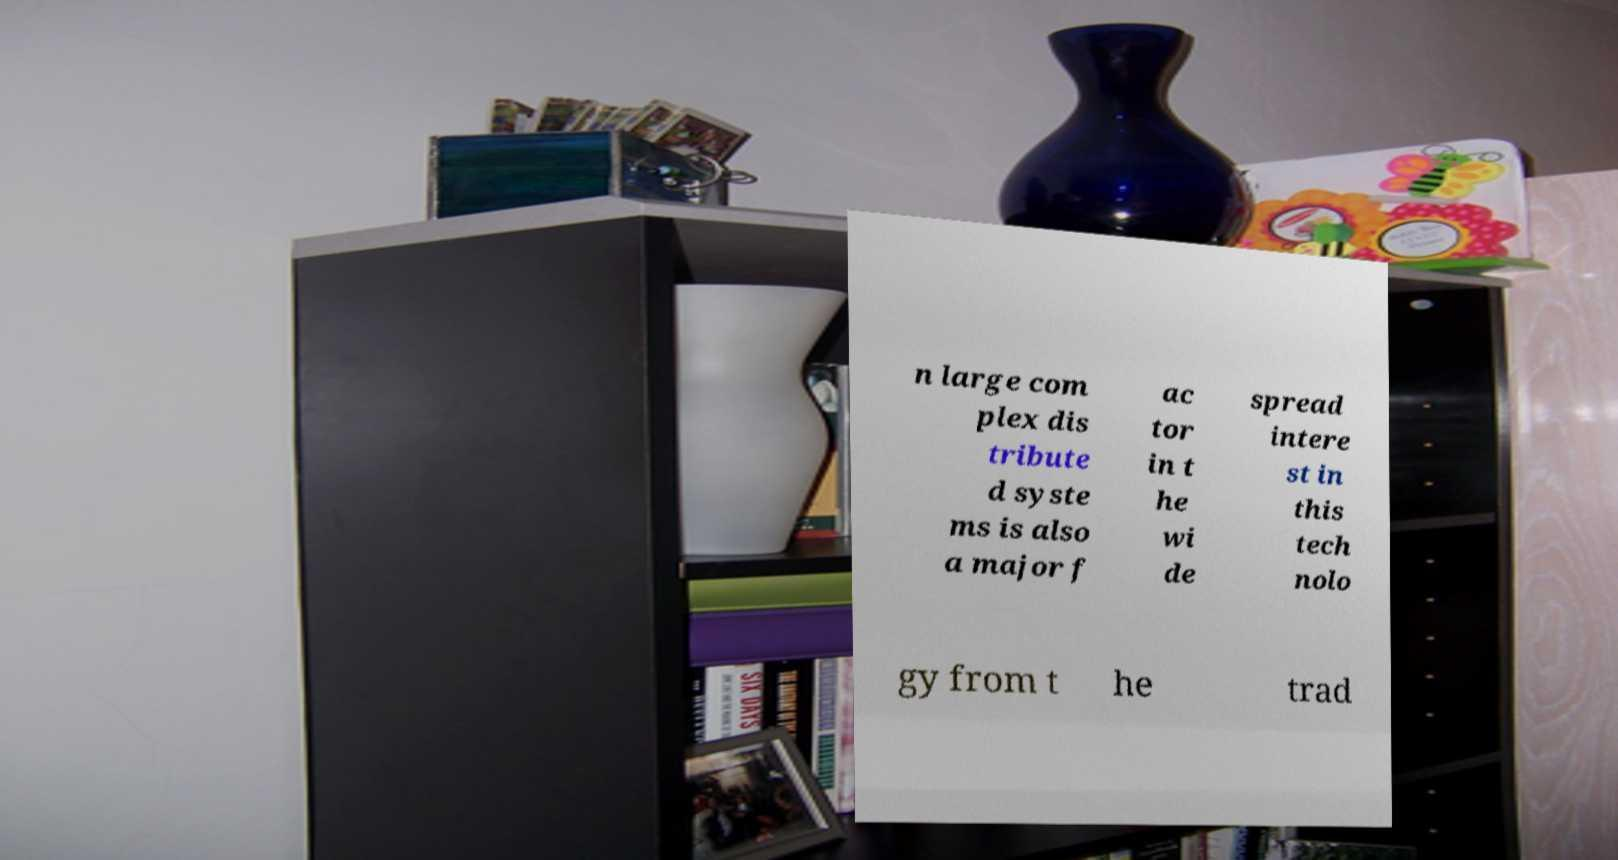Please read and relay the text visible in this image. What does it say? n large com plex dis tribute d syste ms is also a major f ac tor in t he wi de spread intere st in this tech nolo gy from t he trad 